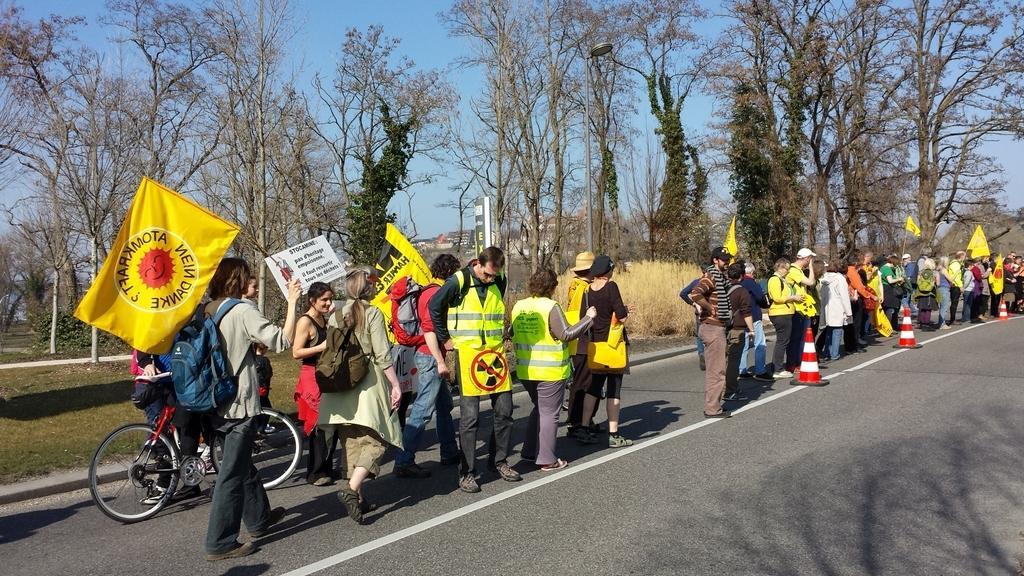Describe this image in one or two sentences. In this image are people standing on a road holding flags in their hands, in the background there are trees. 